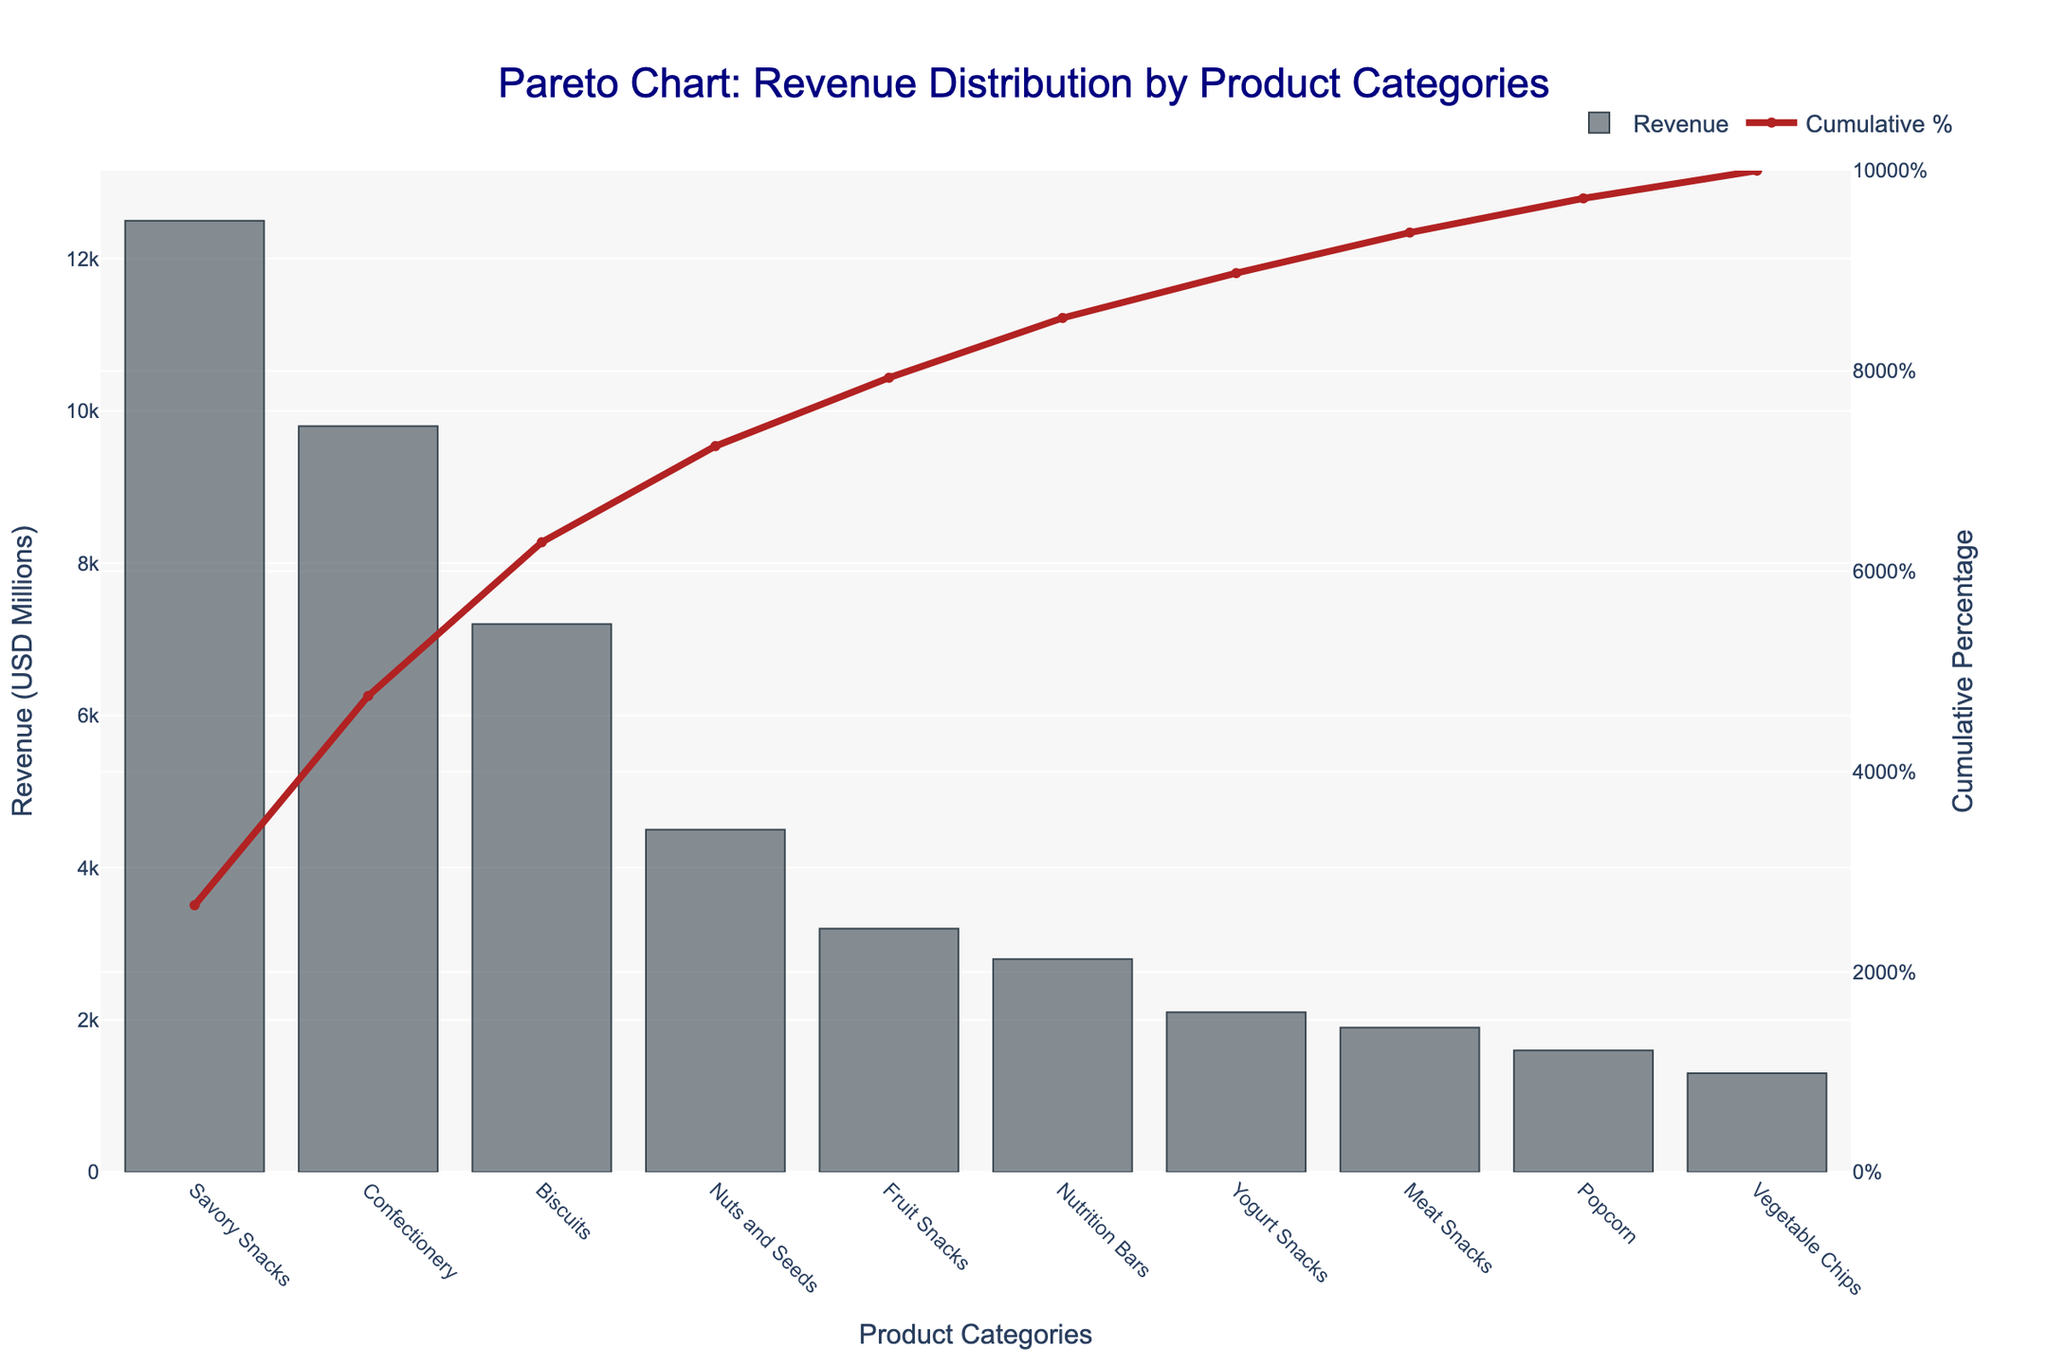what is the title of the plot? The title is usually the first text element displayed at the top center of the chart, indicating what the chart is about.
Answer: Pareto Chart: Revenue Distribution by Product Categories what is the revenue for Biscuits? Find "Biscuits" on the x-axis and look at the height of the corresponding bar on the y-axis.
Answer: 7200 which product category has the highest revenue? Identify the tallest bar in the bar chart; its label on the x-axis will be the category with the highest revenue.
Answer: Savory Snacks what is the cumulative percentage at "Fruit Snacks"? Locate "Fruit Snacks" on the x-axis, then find the corresponding point on the "Cumulative %" line chart.
Answer: 85% how many product categories are displayed? Count the number of bars or labels on the x-axis.
Answer: 10 what is the difference in revenue between Confectionery and Yogurt Snacks? Find the revenue for both categories on the y-axis (9800 for Confectionery and 2100 for Yogurt Snacks) and subtract the smaller value from the larger one, 9800 - 2100.
Answer: 7700 which product categories contribute to the first 50% of the cumulative revenue? Look at the x-axis where the cumulative percentage line crosses 50% and list the product categories up to that point.
Answer: Savory Snacks and Confectionery is the cumulative percentage trend upward or downward? Observe the line chart; since the cumulative percentage can only increase as you move right, it's upward.
Answer: Upward what is the combined revenue for Nutrition Bars and Meat Snacks? Find the revenue for both categories (2800 for Nutrition Bars and 1900 for Meat Snacks) and add them together, 2800 + 1900.
Answer: 4700 